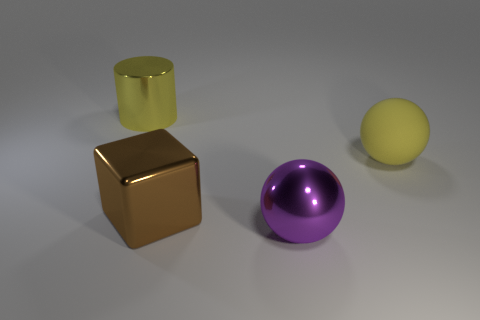There is a ball that is the same color as the large cylinder; what size is it? large 